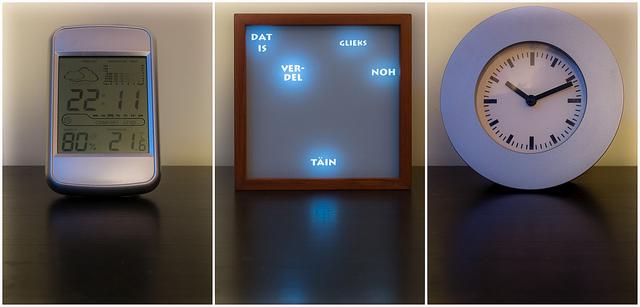Which clock is digital?
Answer briefly. Left. Which clock shows the most accurate time?
Give a very brief answer. Left. Do these clocks all have the same time?
Quick response, please. Yes. 